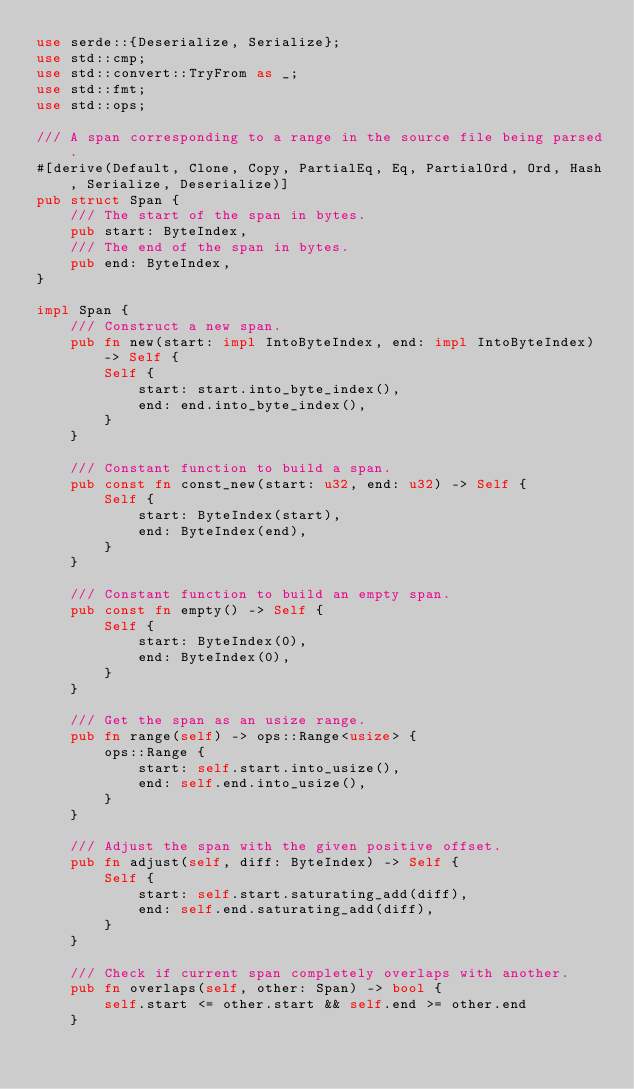Convert code to text. <code><loc_0><loc_0><loc_500><loc_500><_Rust_>use serde::{Deserialize, Serialize};
use std::cmp;
use std::convert::TryFrom as _;
use std::fmt;
use std::ops;

/// A span corresponding to a range in the source file being parsed.
#[derive(Default, Clone, Copy, PartialEq, Eq, PartialOrd, Ord, Hash, Serialize, Deserialize)]
pub struct Span {
    /// The start of the span in bytes.
    pub start: ByteIndex,
    /// The end of the span in bytes.
    pub end: ByteIndex,
}

impl Span {
    /// Construct a new span.
    pub fn new(start: impl IntoByteIndex, end: impl IntoByteIndex) -> Self {
        Self {
            start: start.into_byte_index(),
            end: end.into_byte_index(),
        }
    }

    /// Constant function to build a span.
    pub const fn const_new(start: u32, end: u32) -> Self {
        Self {
            start: ByteIndex(start),
            end: ByteIndex(end),
        }
    }

    /// Constant function to build an empty span.
    pub const fn empty() -> Self {
        Self {
            start: ByteIndex(0),
            end: ByteIndex(0),
        }
    }

    /// Get the span as an usize range.
    pub fn range(self) -> ops::Range<usize> {
        ops::Range {
            start: self.start.into_usize(),
            end: self.end.into_usize(),
        }
    }

    /// Adjust the span with the given positive offset.
    pub fn adjust(self, diff: ByteIndex) -> Self {
        Self {
            start: self.start.saturating_add(diff),
            end: self.end.saturating_add(diff),
        }
    }

    /// Check if current span completely overlaps with another.
    pub fn overlaps(self, other: Span) -> bool {
        self.start <= other.start && self.end >= other.end
    }
</code> 